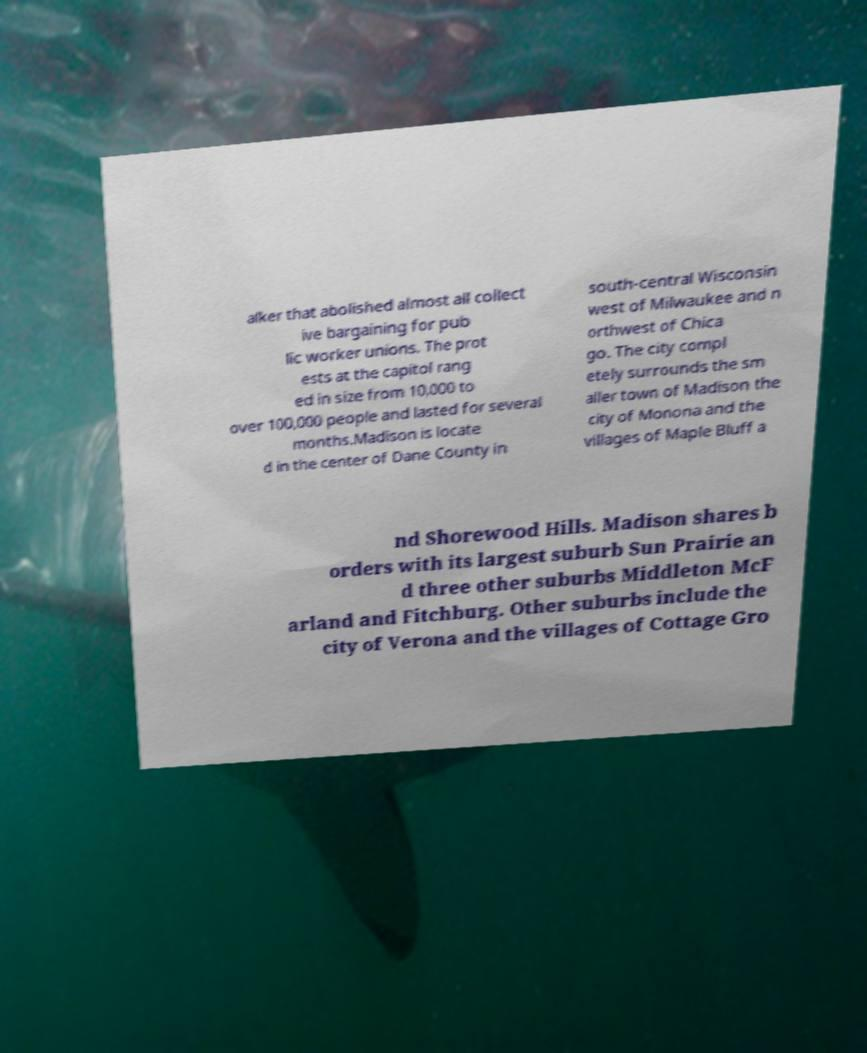Could you extract and type out the text from this image? alker that abolished almost all collect ive bargaining for pub lic worker unions. The prot ests at the capitol rang ed in size from 10,000 to over 100,000 people and lasted for several months.Madison is locate d in the center of Dane County in south-central Wisconsin west of Milwaukee and n orthwest of Chica go. The city compl etely surrounds the sm aller town of Madison the city of Monona and the villages of Maple Bluff a nd Shorewood Hills. Madison shares b orders with its largest suburb Sun Prairie an d three other suburbs Middleton McF arland and Fitchburg. Other suburbs include the city of Verona and the villages of Cottage Gro 